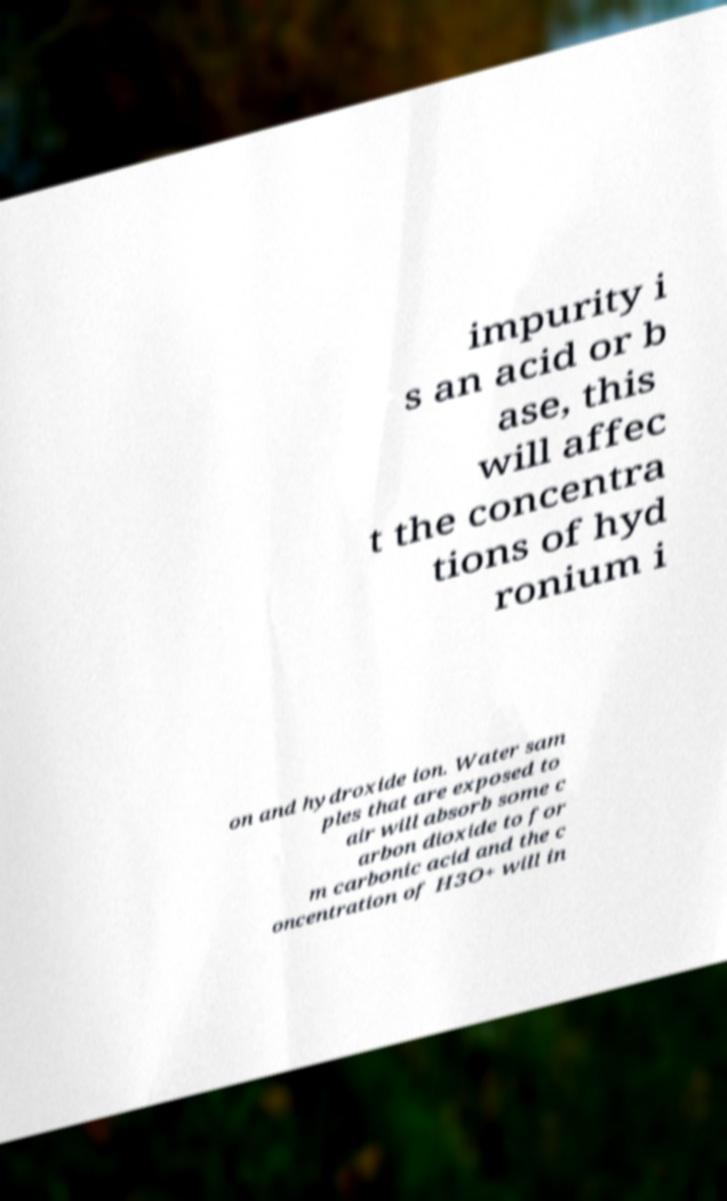For documentation purposes, I need the text within this image transcribed. Could you provide that? impurity i s an acid or b ase, this will affec t the concentra tions of hyd ronium i on and hydroxide ion. Water sam ples that are exposed to air will absorb some c arbon dioxide to for m carbonic acid and the c oncentration of H3O+ will in 